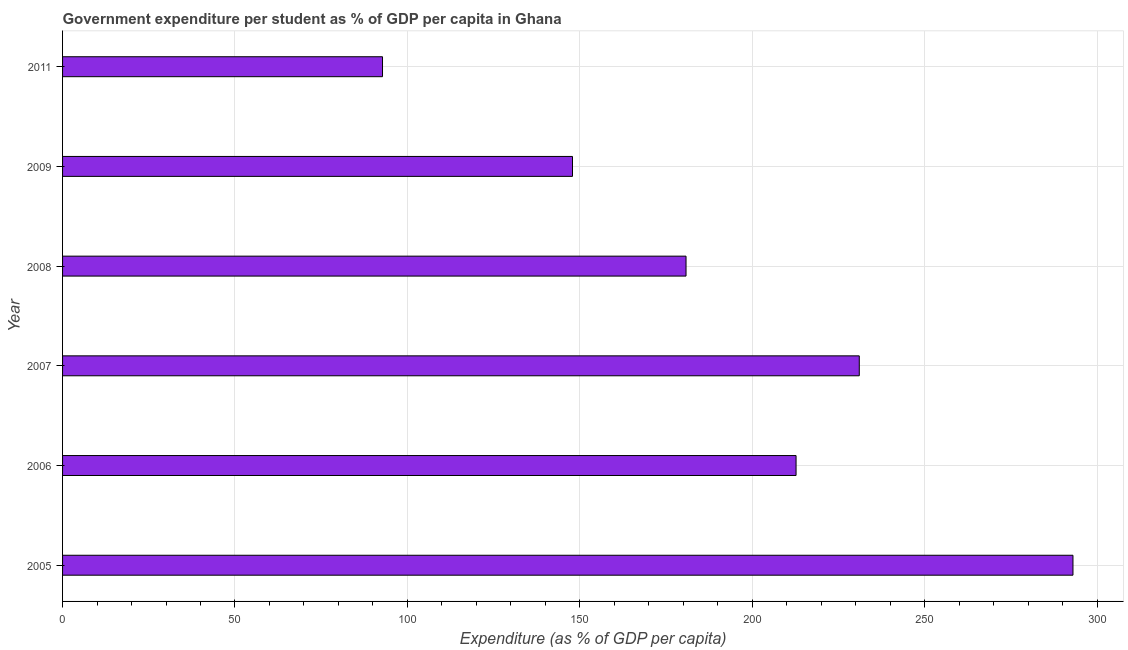Does the graph contain any zero values?
Ensure brevity in your answer.  No. Does the graph contain grids?
Provide a short and direct response. Yes. What is the title of the graph?
Your answer should be very brief. Government expenditure per student as % of GDP per capita in Ghana. What is the label or title of the X-axis?
Offer a terse response. Expenditure (as % of GDP per capita). What is the government expenditure per student in 2011?
Your answer should be very brief. 92.78. Across all years, what is the maximum government expenditure per student?
Your answer should be compact. 293.01. Across all years, what is the minimum government expenditure per student?
Keep it short and to the point. 92.78. What is the sum of the government expenditure per student?
Ensure brevity in your answer.  1158.23. What is the difference between the government expenditure per student in 2007 and 2008?
Make the answer very short. 50.24. What is the average government expenditure per student per year?
Provide a succinct answer. 193.04. What is the median government expenditure per student?
Your answer should be very brief. 196.76. In how many years, is the government expenditure per student greater than 150 %?
Provide a short and direct response. 4. Do a majority of the years between 2009 and 2005 (inclusive) have government expenditure per student greater than 60 %?
Give a very brief answer. Yes. What is the ratio of the government expenditure per student in 2009 to that in 2011?
Offer a very short reply. 1.59. Is the government expenditure per student in 2006 less than that in 2007?
Make the answer very short. Yes. Is the difference between the government expenditure per student in 2007 and 2011 greater than the difference between any two years?
Your response must be concise. No. What is the difference between the highest and the second highest government expenditure per student?
Provide a succinct answer. 61.97. Is the sum of the government expenditure per student in 2007 and 2011 greater than the maximum government expenditure per student across all years?
Keep it short and to the point. Yes. What is the difference between the highest and the lowest government expenditure per student?
Your answer should be very brief. 200.23. In how many years, is the government expenditure per student greater than the average government expenditure per student taken over all years?
Make the answer very short. 3. How many bars are there?
Your answer should be compact. 6. Are all the bars in the graph horizontal?
Your answer should be compact. Yes. How many years are there in the graph?
Keep it short and to the point. 6. What is the difference between two consecutive major ticks on the X-axis?
Provide a succinct answer. 50. Are the values on the major ticks of X-axis written in scientific E-notation?
Ensure brevity in your answer.  No. What is the Expenditure (as % of GDP per capita) of 2005?
Your answer should be compact. 293.01. What is the Expenditure (as % of GDP per capita) in 2006?
Offer a terse response. 212.71. What is the Expenditure (as % of GDP per capita) in 2007?
Give a very brief answer. 231.04. What is the Expenditure (as % of GDP per capita) of 2008?
Give a very brief answer. 180.8. What is the Expenditure (as % of GDP per capita) of 2009?
Offer a terse response. 147.88. What is the Expenditure (as % of GDP per capita) of 2011?
Give a very brief answer. 92.78. What is the difference between the Expenditure (as % of GDP per capita) in 2005 and 2006?
Keep it short and to the point. 80.3. What is the difference between the Expenditure (as % of GDP per capita) in 2005 and 2007?
Your response must be concise. 61.97. What is the difference between the Expenditure (as % of GDP per capita) in 2005 and 2008?
Your answer should be very brief. 112.21. What is the difference between the Expenditure (as % of GDP per capita) in 2005 and 2009?
Make the answer very short. 145.14. What is the difference between the Expenditure (as % of GDP per capita) in 2005 and 2011?
Provide a short and direct response. 200.23. What is the difference between the Expenditure (as % of GDP per capita) in 2006 and 2007?
Provide a short and direct response. -18.33. What is the difference between the Expenditure (as % of GDP per capita) in 2006 and 2008?
Give a very brief answer. 31.91. What is the difference between the Expenditure (as % of GDP per capita) in 2006 and 2009?
Your answer should be compact. 64.83. What is the difference between the Expenditure (as % of GDP per capita) in 2006 and 2011?
Make the answer very short. 119.92. What is the difference between the Expenditure (as % of GDP per capita) in 2007 and 2008?
Keep it short and to the point. 50.24. What is the difference between the Expenditure (as % of GDP per capita) in 2007 and 2009?
Offer a very short reply. 83.17. What is the difference between the Expenditure (as % of GDP per capita) in 2007 and 2011?
Make the answer very short. 138.26. What is the difference between the Expenditure (as % of GDP per capita) in 2008 and 2009?
Provide a short and direct response. 32.93. What is the difference between the Expenditure (as % of GDP per capita) in 2008 and 2011?
Your answer should be very brief. 88.02. What is the difference between the Expenditure (as % of GDP per capita) in 2009 and 2011?
Keep it short and to the point. 55.09. What is the ratio of the Expenditure (as % of GDP per capita) in 2005 to that in 2006?
Your response must be concise. 1.38. What is the ratio of the Expenditure (as % of GDP per capita) in 2005 to that in 2007?
Provide a short and direct response. 1.27. What is the ratio of the Expenditure (as % of GDP per capita) in 2005 to that in 2008?
Your answer should be very brief. 1.62. What is the ratio of the Expenditure (as % of GDP per capita) in 2005 to that in 2009?
Make the answer very short. 1.98. What is the ratio of the Expenditure (as % of GDP per capita) in 2005 to that in 2011?
Provide a succinct answer. 3.16. What is the ratio of the Expenditure (as % of GDP per capita) in 2006 to that in 2007?
Offer a very short reply. 0.92. What is the ratio of the Expenditure (as % of GDP per capita) in 2006 to that in 2008?
Make the answer very short. 1.18. What is the ratio of the Expenditure (as % of GDP per capita) in 2006 to that in 2009?
Ensure brevity in your answer.  1.44. What is the ratio of the Expenditure (as % of GDP per capita) in 2006 to that in 2011?
Your answer should be very brief. 2.29. What is the ratio of the Expenditure (as % of GDP per capita) in 2007 to that in 2008?
Your answer should be very brief. 1.28. What is the ratio of the Expenditure (as % of GDP per capita) in 2007 to that in 2009?
Your answer should be compact. 1.56. What is the ratio of the Expenditure (as % of GDP per capita) in 2007 to that in 2011?
Provide a succinct answer. 2.49. What is the ratio of the Expenditure (as % of GDP per capita) in 2008 to that in 2009?
Provide a short and direct response. 1.22. What is the ratio of the Expenditure (as % of GDP per capita) in 2008 to that in 2011?
Provide a succinct answer. 1.95. What is the ratio of the Expenditure (as % of GDP per capita) in 2009 to that in 2011?
Your response must be concise. 1.59. 